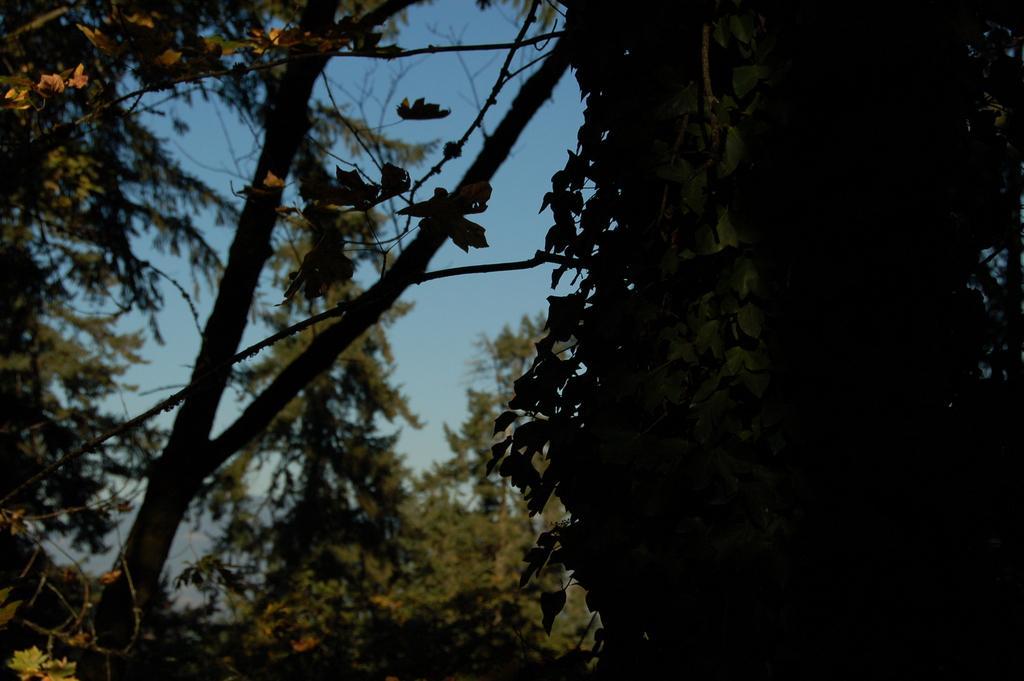How would you summarize this image in a sentence or two? In this image we can see many trees. There is a sky in the image. There is a hill in the image. 